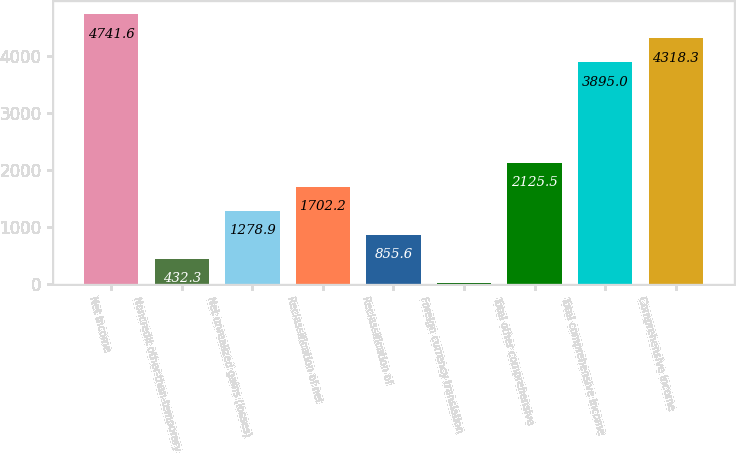Convert chart. <chart><loc_0><loc_0><loc_500><loc_500><bar_chart><fcel>Net income<fcel>Noncredit other-than-temporary<fcel>Net unrealized gains (losses)<fcel>Reclassification of net<fcel>Reclassification of<fcel>Foreign currency translation<fcel>Total other comprehensive<fcel>Total comprehensive income<fcel>Comprehensive income<nl><fcel>4741.6<fcel>432.3<fcel>1278.9<fcel>1702.2<fcel>855.6<fcel>9<fcel>2125.5<fcel>3895<fcel>4318.3<nl></chart> 